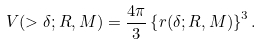<formula> <loc_0><loc_0><loc_500><loc_500>V ( > \delta ; R , M ) = \frac { 4 \pi } { 3 } \left \{ r ( \delta ; R , M ) \right \} ^ { 3 } .</formula> 